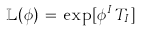Convert formula to latex. <formula><loc_0><loc_0><loc_500><loc_500>\mathbb { L } ( \phi ) \, = \, \exp [ \phi ^ { I } \, T _ { I } ]</formula> 